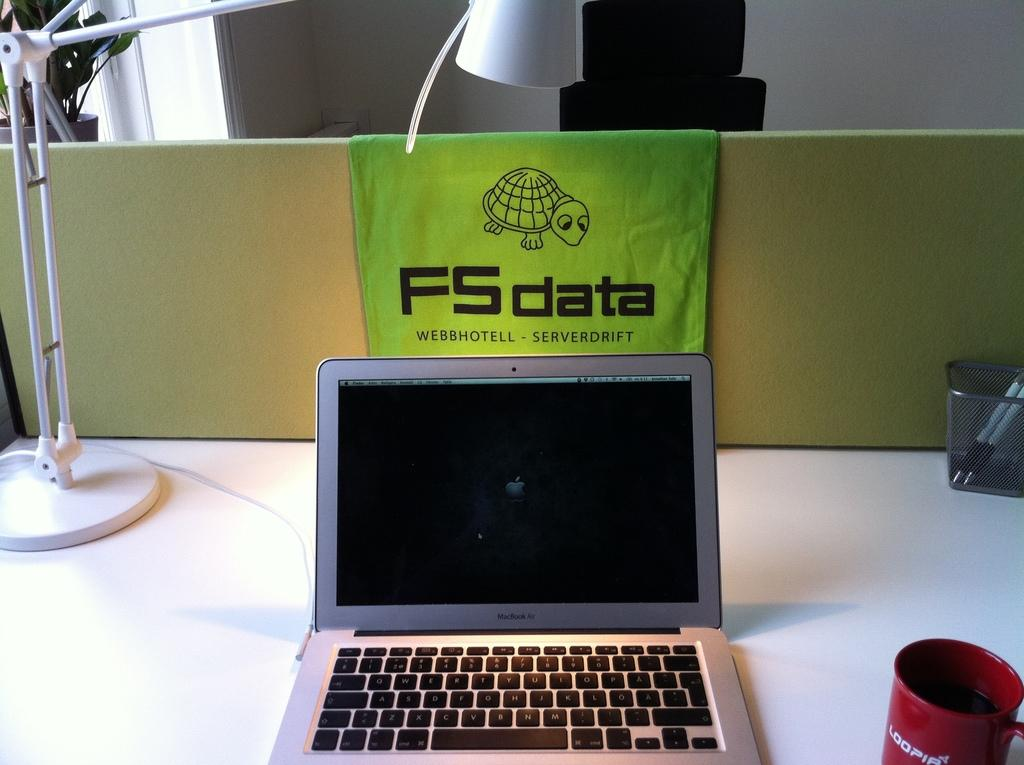<image>
Provide a brief description of the given image. A laptop on a desk with a green FS data towel draped over the back 